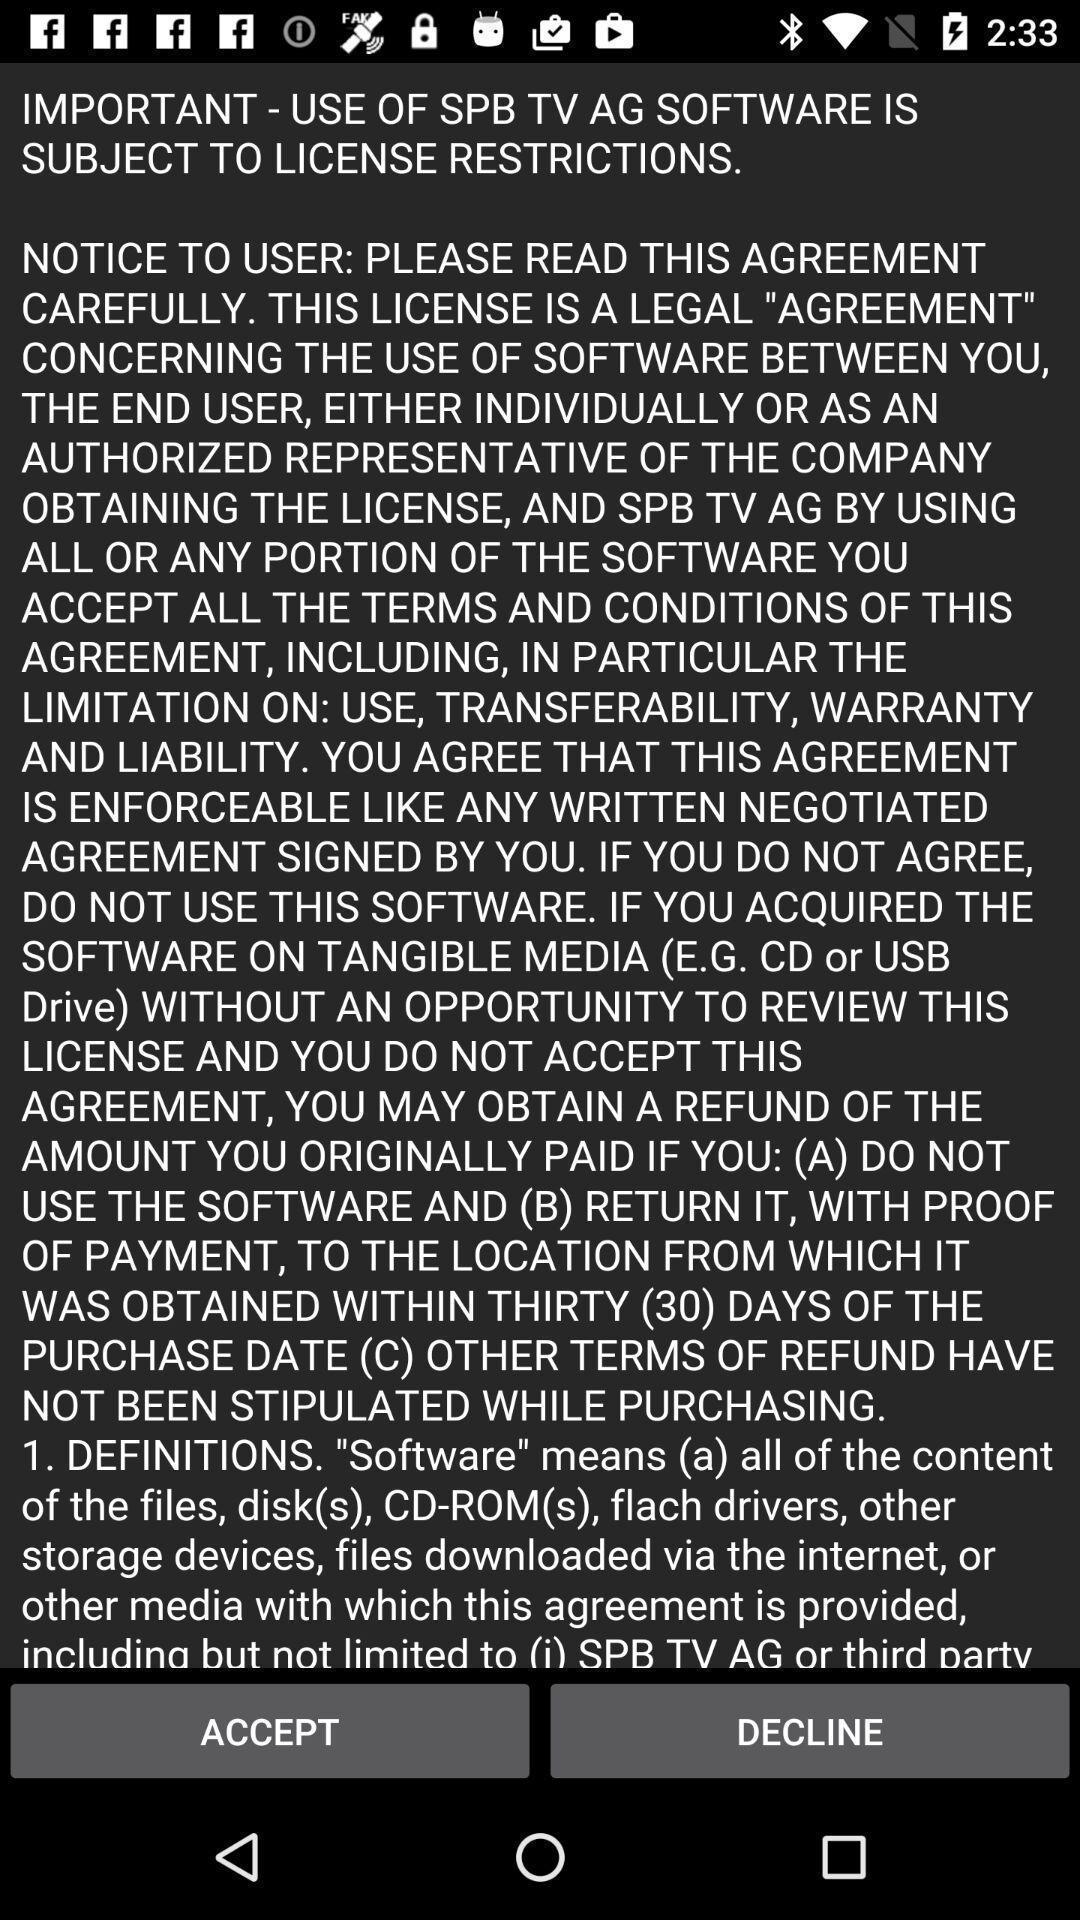What is the overall content of this screenshot? Screen shows license restriction details. 